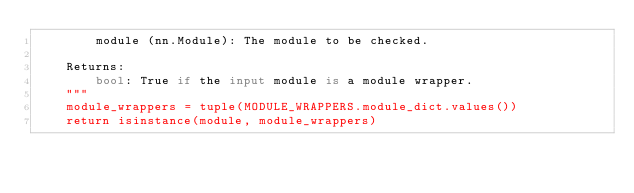<code> <loc_0><loc_0><loc_500><loc_500><_Python_>        module (nn.Module): The module to be checked.

    Returns:
        bool: True if the input module is a module wrapper.
    """
    module_wrappers = tuple(MODULE_WRAPPERS.module_dict.values())
    return isinstance(module, module_wrappers)
</code> 